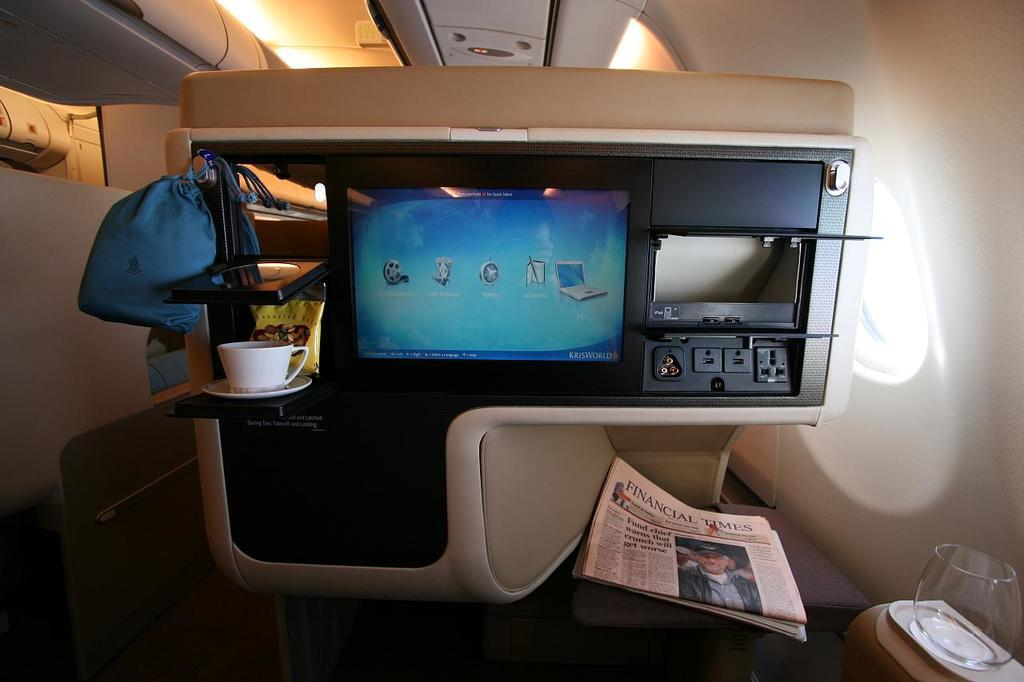<image>
Give a short and clear explanation of the subsequent image. A copy of the Financial Times sits underneath a TV screen on an airplane. 